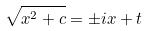Convert formula to latex. <formula><loc_0><loc_0><loc_500><loc_500>\sqrt { x ^ { 2 } + c } = \pm i x + t</formula> 